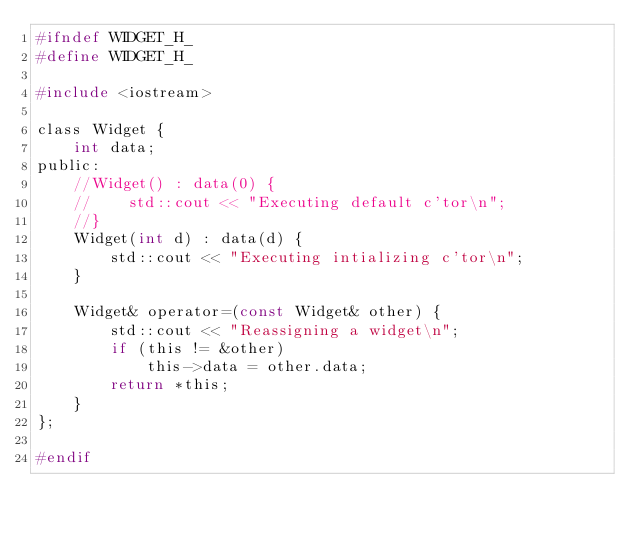<code> <loc_0><loc_0><loc_500><loc_500><_C_>#ifndef WIDGET_H_
#define WIDGET_H_

#include <iostream>

class Widget {
    int data;
public:
    //Widget() : data(0) {
    //    std::cout << "Executing default c'tor\n";
    //}
    Widget(int d) : data(d) {
        std::cout << "Executing intializing c'tor\n";
    }

    Widget& operator=(const Widget& other) {
        std::cout << "Reassigning a widget\n";
        if (this != &other)
            this->data = other.data;
        return *this;
    }
};

#endif
</code> 